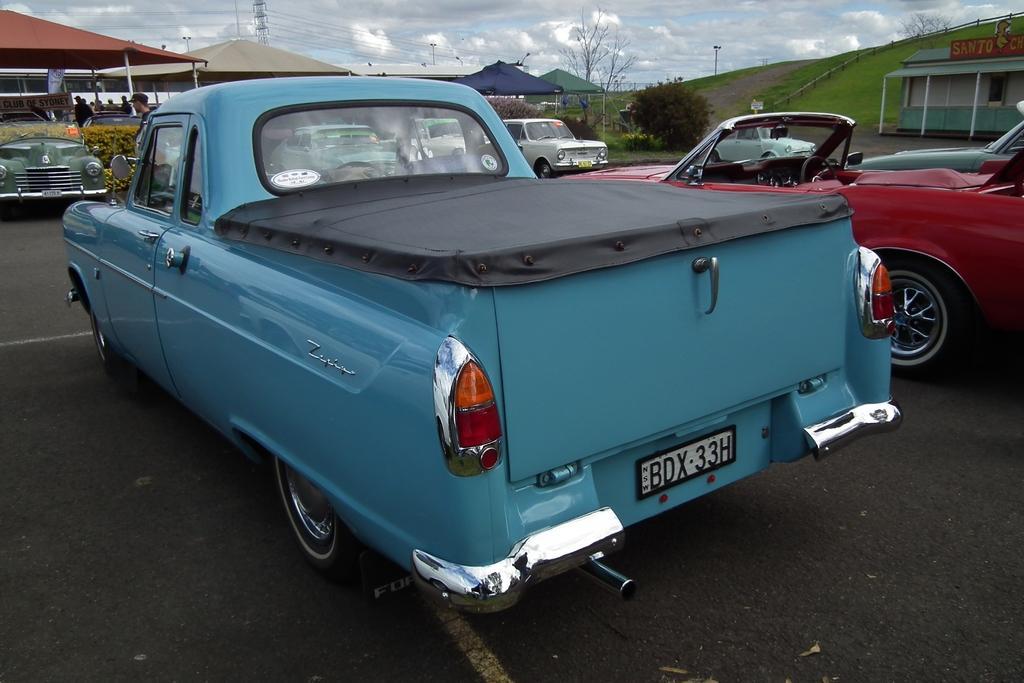Can you describe this image briefly? There are cars parked. There are tents, people, trees, wire, pole and building. 